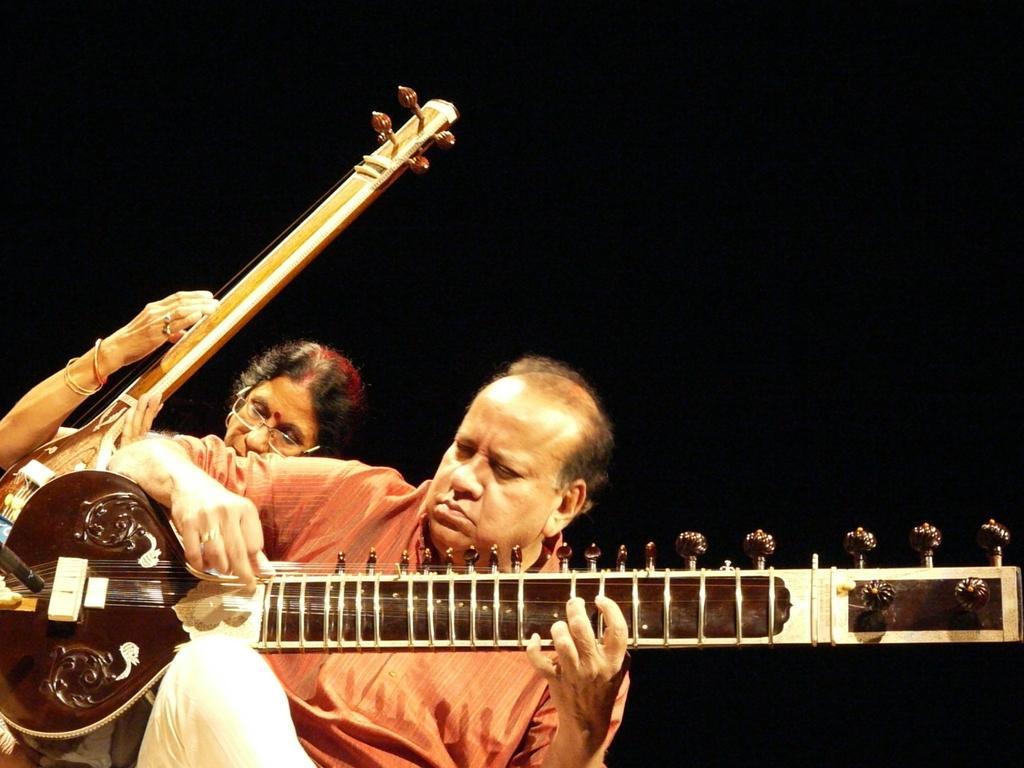How would you summarize this image in a sentence or two? In this Picture we can See a man Wearing a red shirt and White Pant Playing a Indian Guitar. And behind Him a woman wearing Specs also Playing Indian guitar. 